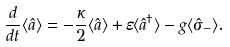<formula> <loc_0><loc_0><loc_500><loc_500>\frac { d } { d t } \langle \hat { a } \rangle = - \frac { \kappa } { 2 } \langle \hat { a } \rangle + \varepsilon \langle \hat { a } ^ { \dagger } \rangle - g \langle \hat { \sigma } _ { - } \rangle .</formula> 